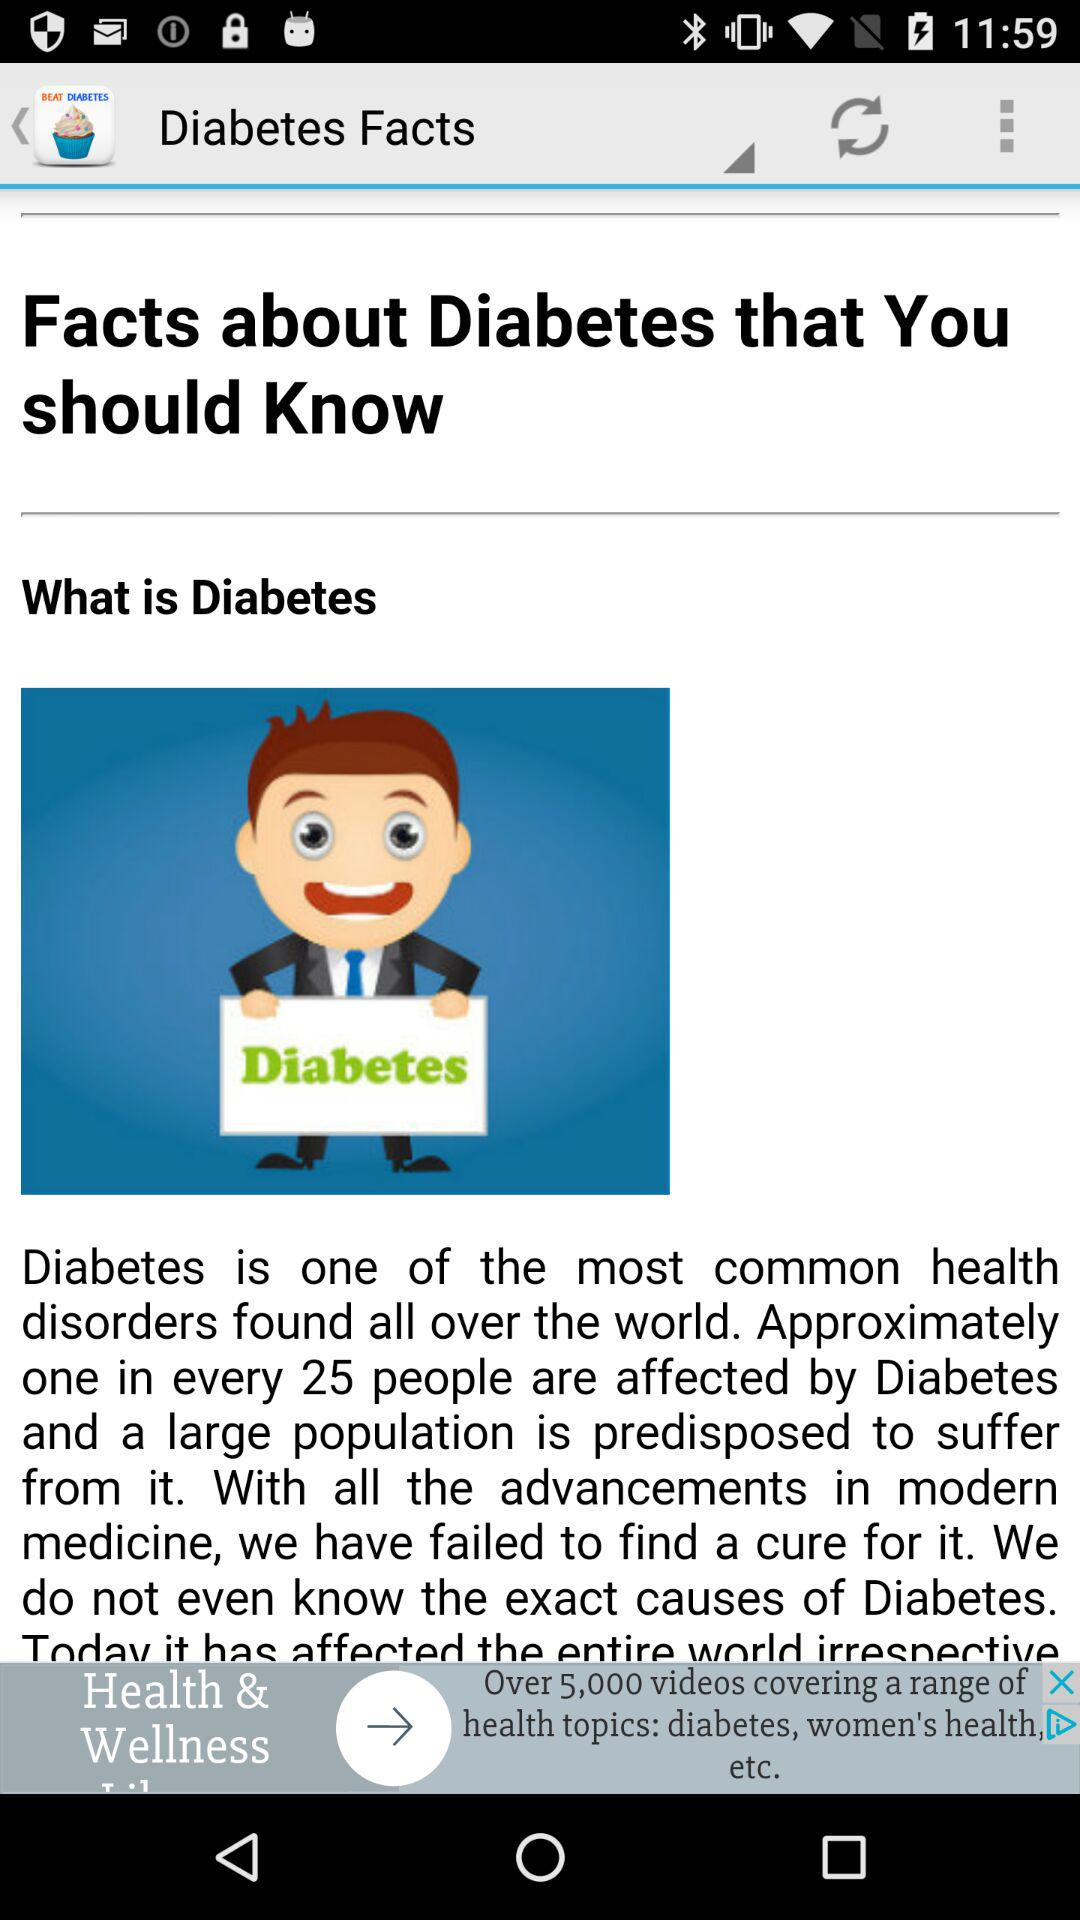What disease has the most common health disorders found all over the world? The disease is diabetes. 